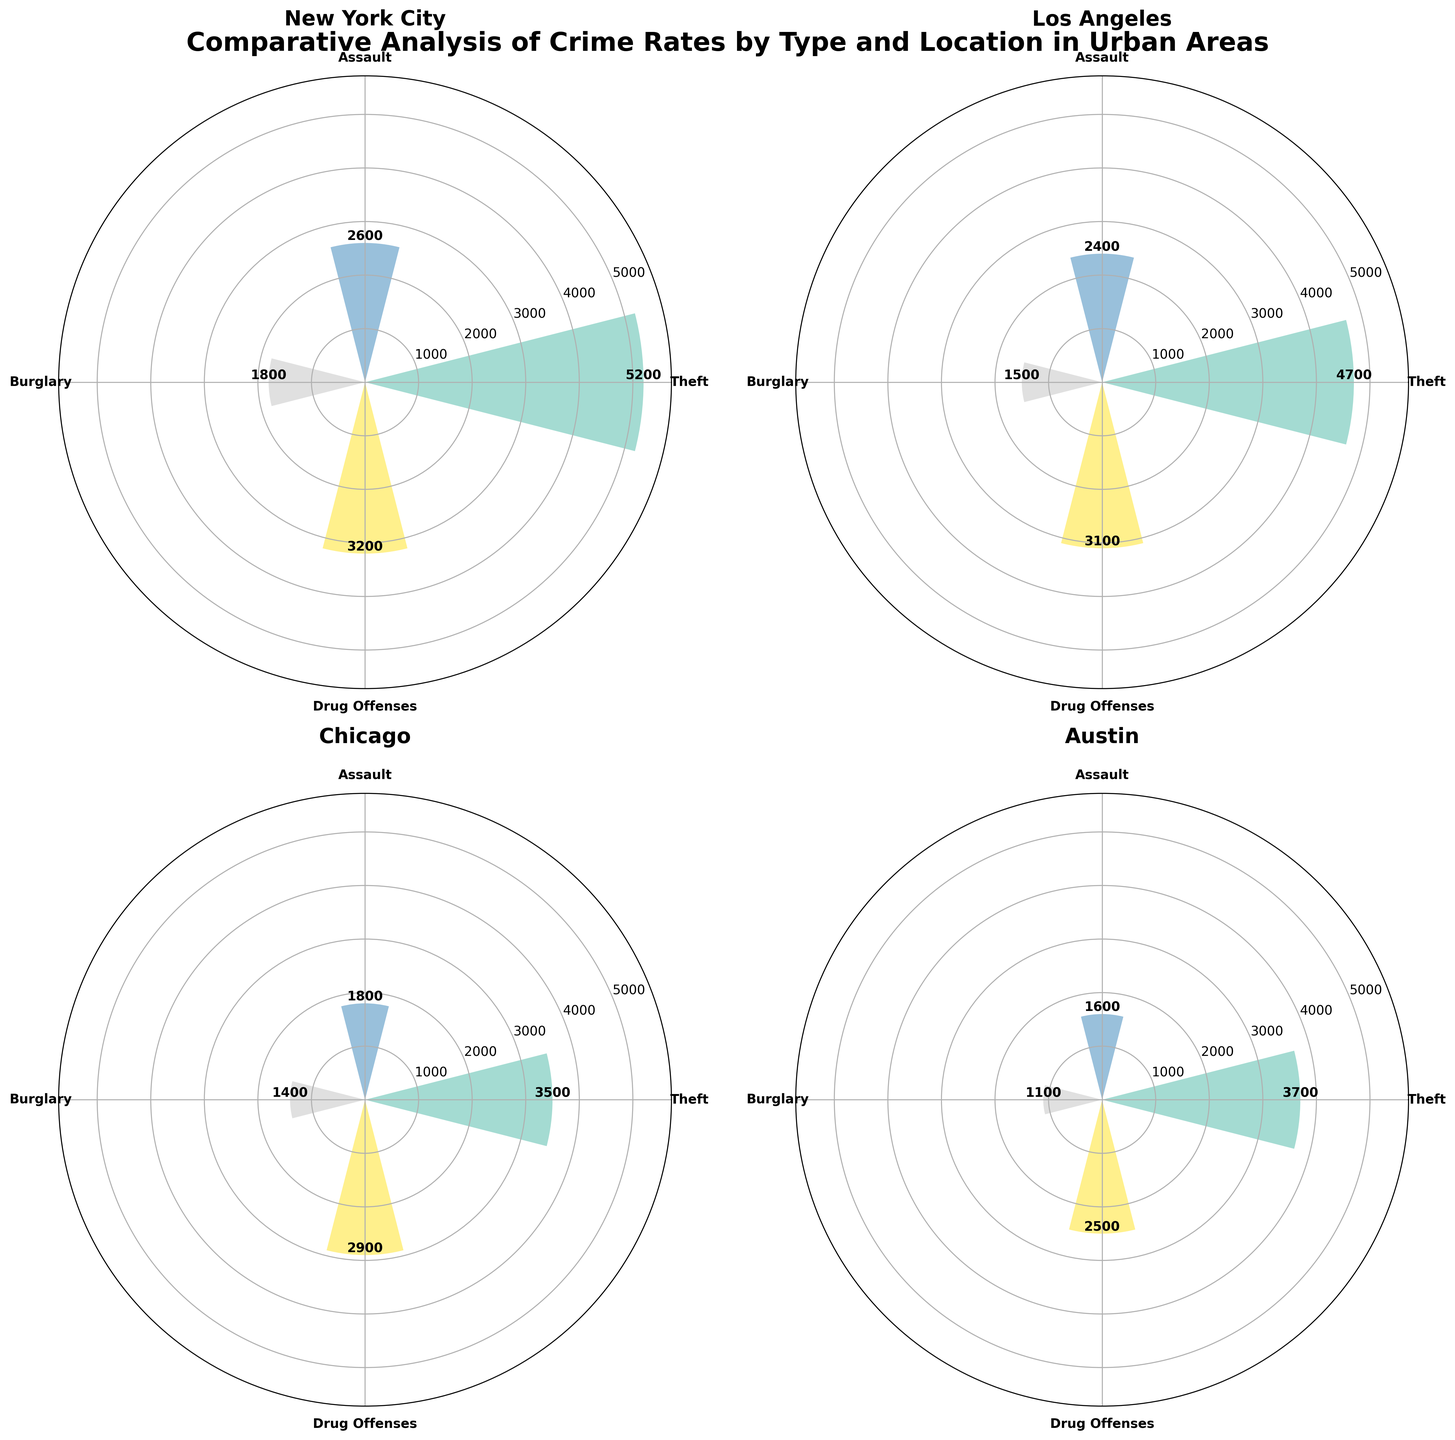What's the title of the overall figure? The title of the overall figure is written at the top of the chart, which is a common practice for labeling figures. The title is clear and concise, describing the content of the figure.
Answer: Comparative Analysis of Crime Rates by Type and Location in Urban Areas Which location has the highest number of drug offense incidents? To find the highest number of drug offense incidents, look at the bar segments representing drug offenses in each polar subplot. The bar for New York City extends further out than the others.
Answer: New York City How does the number of assault incidents in Chicago compare to those in Austin? To compare the assault incidents between Chicago and Austin, observe the height of the bars representing assaults in the respective polar subplots. The assault incidents bar in Chicago extends higher than in Austin.
Answer: Chicago has more assault incidents than Austin What is the total number of theft incidents across all locations? Add the theft incident values from each location: New York City (5200), Los Angeles (4700), Chicago (3500), and Austin (3700). The total is 5200 + 4700 + 3500 + 3700.
Answer: 17100 Which crime type is the least frequent in Los Angeles? Examine the polar subplot for Los Angeles and identify the shortest segment bar. The burglary segment is the shortest among all crime types for this location.
Answer: Burglary How does the maximum crime rate in New York City compare to the maximum crime rate in Austin? Identify the highest bar segment for both New York City and Austin. For New York City, the maximum incident (Theft, 5200) is higher than the maximum incident in Austin (Theft, 3700).
Answer: New York City has a higher maximum crime rate than Austin If you add the number of drug offenses in Los Angeles and Chicago, do the combined incidents exceed those in New York City? Add the drug offense incidents from Los Angeles (3100) and Chicago (2900). Compare their sum to the drug offense incidents in New York City (3200). 3100 + 2900 = 6000, which is greater than 3200.
Answer: Yes What is the most common crime type across all locations? Determine the most common crime type by identifying the crime with the consistently highest bars across all locations. Theft crimes have consistently higher bars than the other crime types in each subplot.
Answer: Theft In terms of burglary incidents, which cities have a higher number than Austin? Compare the heights of the burglary incident bars in New York City (1800), Los Angeles (1500), Chicago (1400), and Austin (1100). New York City, Los Angeles, and Chicago each have burglary incidents higher than Austin.
Answer: New York City, Los Angeles, Chicago 